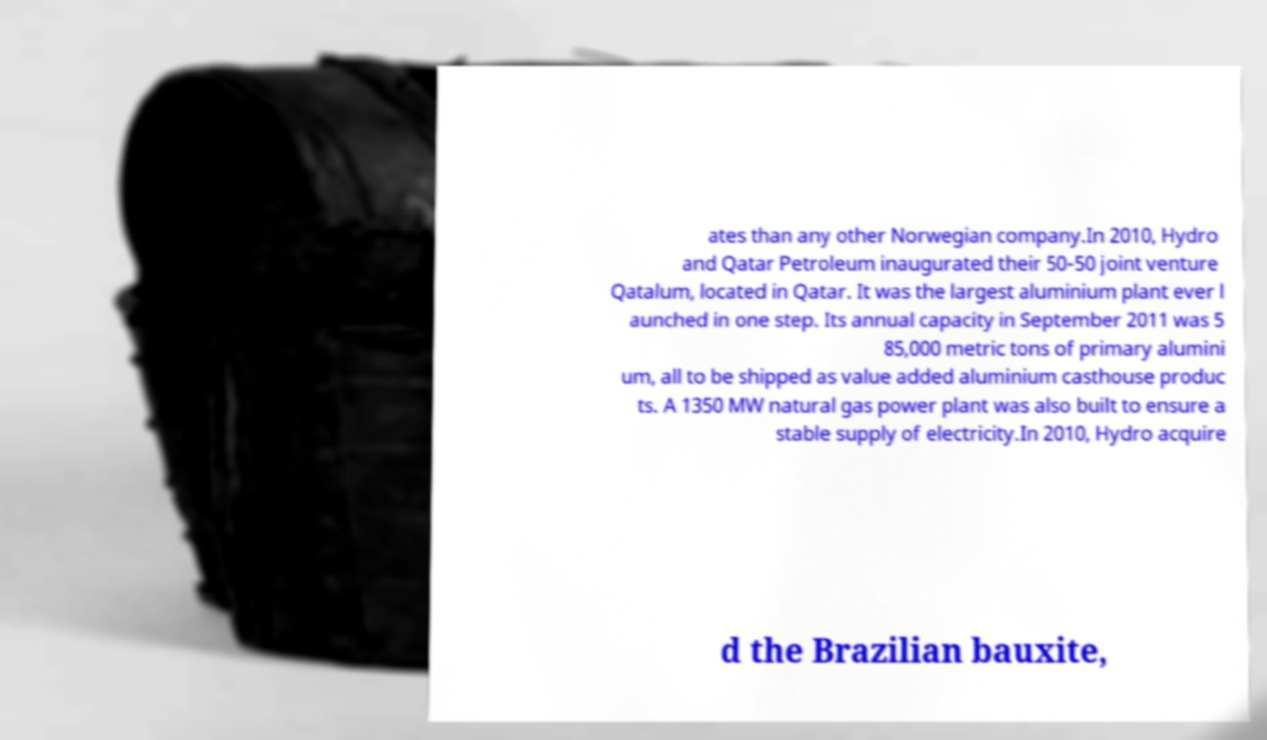I need the written content from this picture converted into text. Can you do that? ates than any other Norwegian company.In 2010, Hydro and Qatar Petroleum inaugurated their 50-50 joint venture Qatalum, located in Qatar. It was the largest aluminium plant ever l aunched in one step. Its annual capacity in September 2011 was 5 85,000 metric tons of primary alumini um, all to be shipped as value added aluminium casthouse produc ts. A 1350 MW natural gas power plant was also built to ensure a stable supply of electricity.In 2010, Hydro acquire d the Brazilian bauxite, 